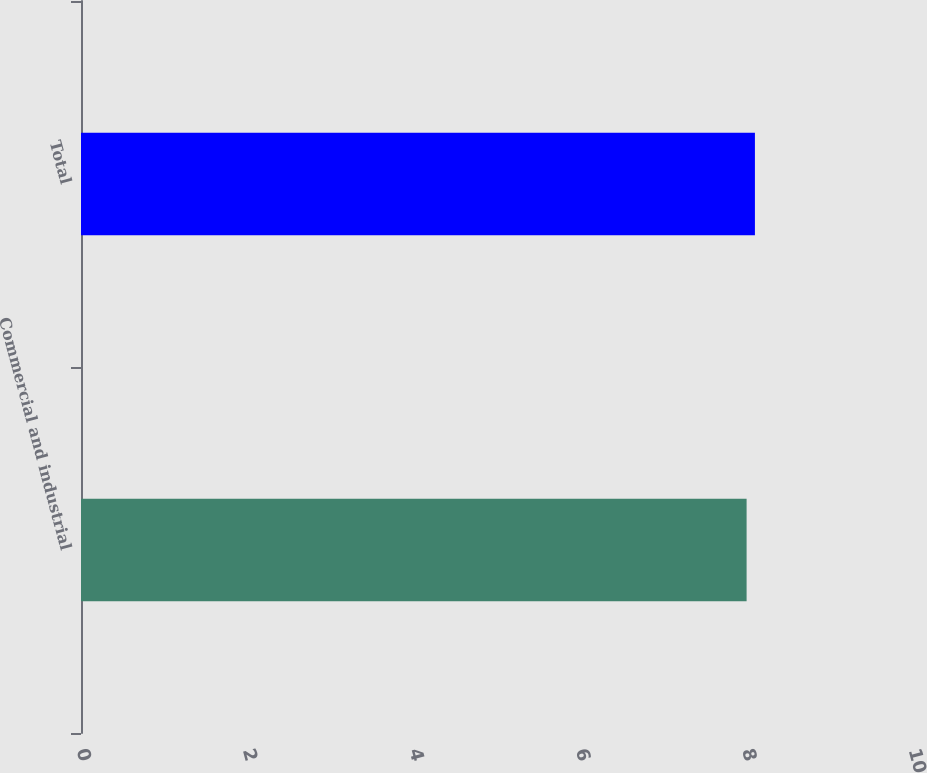Convert chart. <chart><loc_0><loc_0><loc_500><loc_500><bar_chart><fcel>Commercial and industrial<fcel>Total<nl><fcel>8<fcel>8.1<nl></chart> 